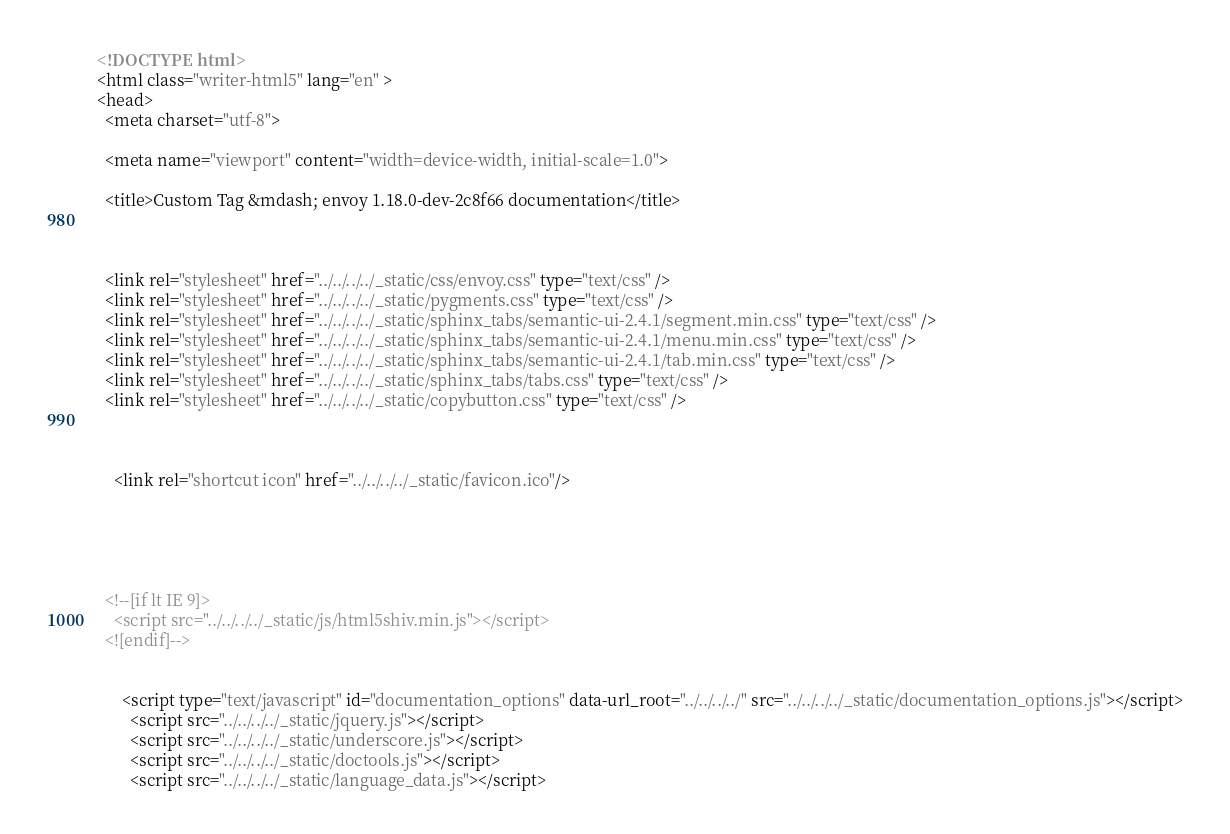<code> <loc_0><loc_0><loc_500><loc_500><_HTML_>

<!DOCTYPE html>
<html class="writer-html5" lang="en" >
<head>
  <meta charset="utf-8">
  
  <meta name="viewport" content="width=device-width, initial-scale=1.0">
  
  <title>Custom Tag &mdash; envoy 1.18.0-dev-2c8f66 documentation</title>
  

  
  <link rel="stylesheet" href="../../../../_static/css/envoy.css" type="text/css" />
  <link rel="stylesheet" href="../../../../_static/pygments.css" type="text/css" />
  <link rel="stylesheet" href="../../../../_static/sphinx_tabs/semantic-ui-2.4.1/segment.min.css" type="text/css" />
  <link rel="stylesheet" href="../../../../_static/sphinx_tabs/semantic-ui-2.4.1/menu.min.css" type="text/css" />
  <link rel="stylesheet" href="../../../../_static/sphinx_tabs/semantic-ui-2.4.1/tab.min.css" type="text/css" />
  <link rel="stylesheet" href="../../../../_static/sphinx_tabs/tabs.css" type="text/css" />
  <link rel="stylesheet" href="../../../../_static/copybutton.css" type="text/css" />

  
  
    <link rel="shortcut icon" href="../../../../_static/favicon.ico"/>
  
  
  

  
  <!--[if lt IE 9]>
    <script src="../../../../_static/js/html5shiv.min.js"></script>
  <![endif]-->
  
    
      <script type="text/javascript" id="documentation_options" data-url_root="../../../../" src="../../../../_static/documentation_options.js"></script>
        <script src="../../../../_static/jquery.js"></script>
        <script src="../../../../_static/underscore.js"></script>
        <script src="../../../../_static/doctools.js"></script>
        <script src="../../../../_static/language_data.js"></script></code> 